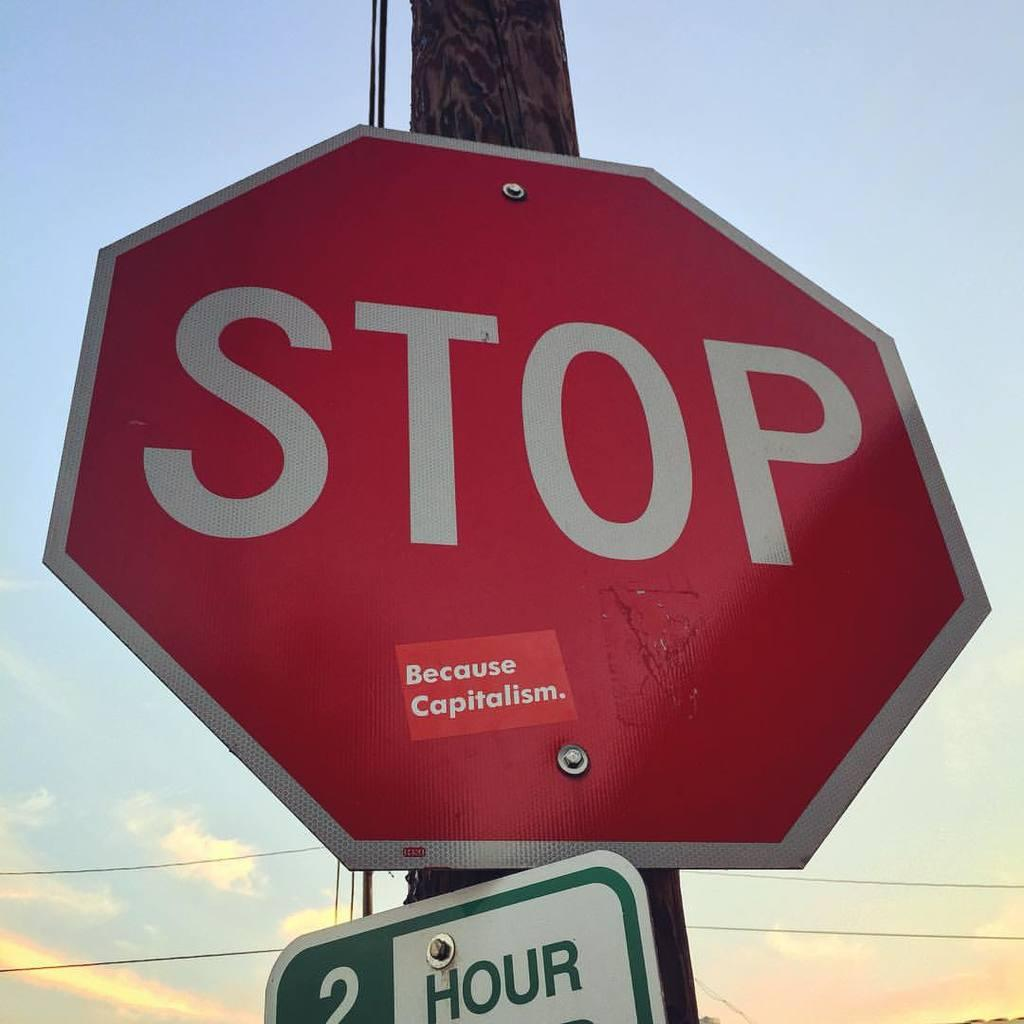<image>
Offer a succinct explanation of the picture presented. A stop sign with a sticker on it that says Because Capitalism. 